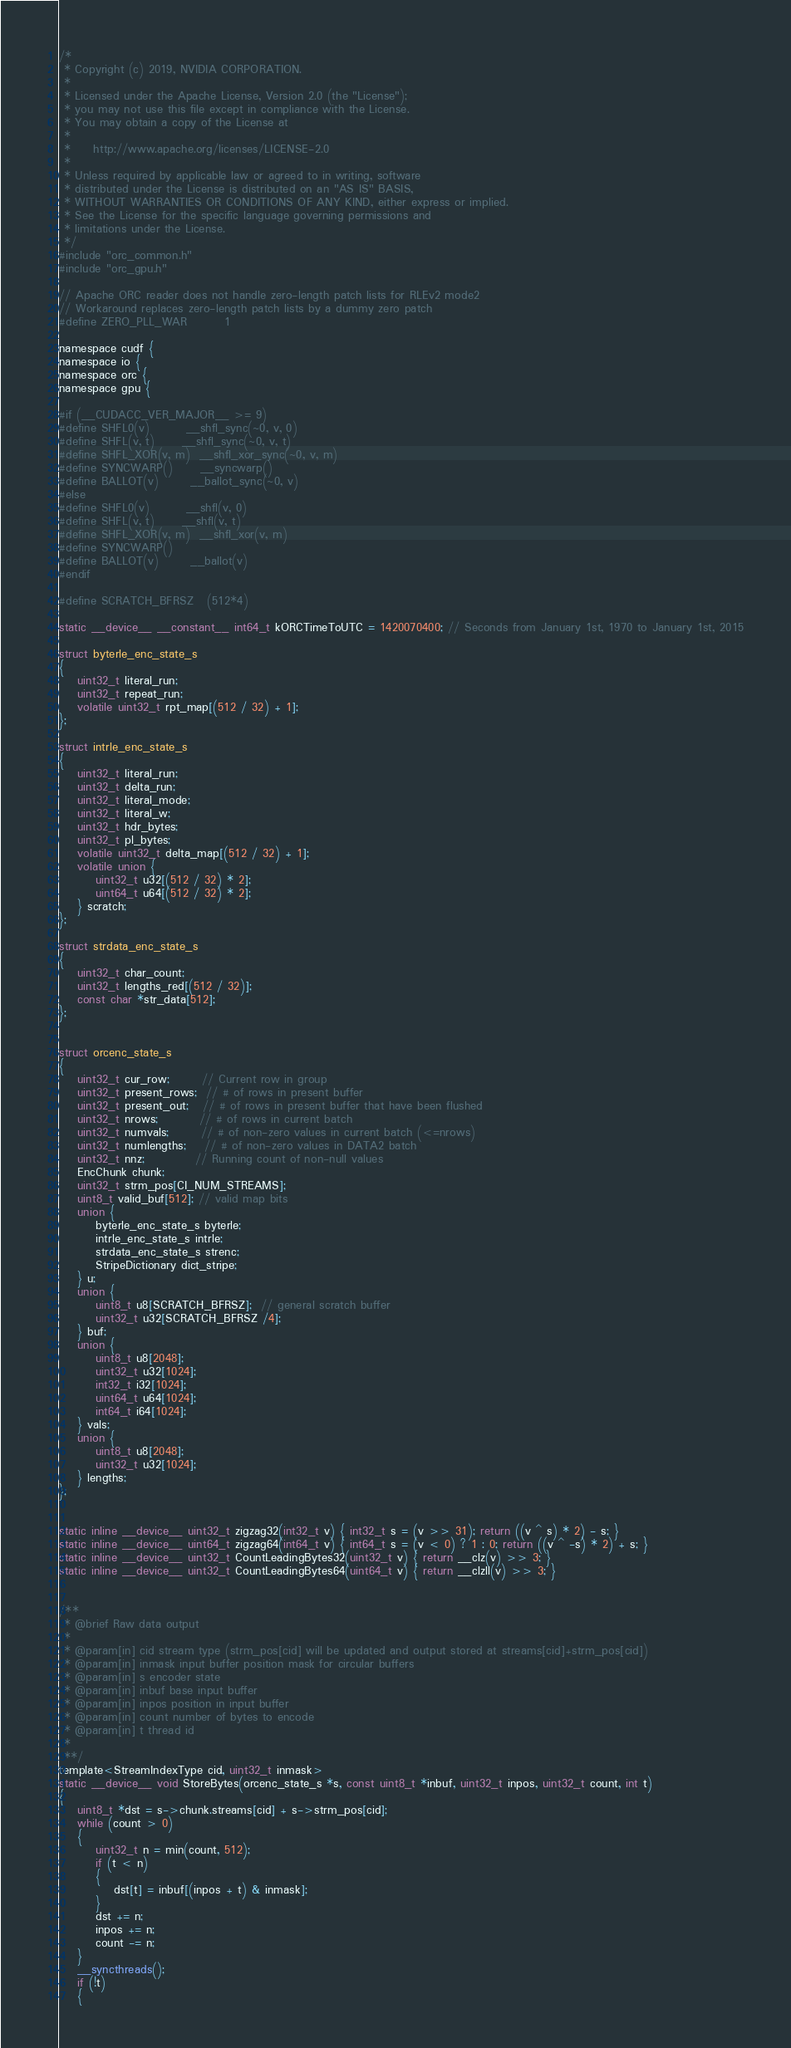<code> <loc_0><loc_0><loc_500><loc_500><_Cuda_>/*
 * Copyright (c) 2019, NVIDIA CORPORATION.
 *
 * Licensed under the Apache License, Version 2.0 (the "License");
 * you may not use this file except in compliance with the License.
 * You may obtain a copy of the License at
 *
 *     http://www.apache.org/licenses/LICENSE-2.0
 *
 * Unless required by applicable law or agreed to in writing, software
 * distributed under the License is distributed on an "AS IS" BASIS,
 * WITHOUT WARRANTIES OR CONDITIONS OF ANY KIND, either express or implied.
 * See the License for the specific language governing permissions and
 * limitations under the License.
 */
#include "orc_common.h"
#include "orc_gpu.h"

// Apache ORC reader does not handle zero-length patch lists for RLEv2 mode2
// Workaround replaces zero-length patch lists by a dummy zero patch
#define ZERO_PLL_WAR        1

namespace cudf {
namespace io {
namespace orc {
namespace gpu {

#if (__CUDACC_VER_MAJOR__ >= 9)
#define SHFL0(v)        __shfl_sync(~0, v, 0)
#define SHFL(v, t)      __shfl_sync(~0, v, t)
#define SHFL_XOR(v, m)  __shfl_xor_sync(~0, v, m)
#define SYNCWARP()      __syncwarp()
#define BALLOT(v)       __ballot_sync(~0, v)
#else
#define SHFL0(v)        __shfl(v, 0)
#define SHFL(v, t)      __shfl(v, t)
#define SHFL_XOR(v, m)  __shfl_xor(v, m)
#define SYNCWARP()
#define BALLOT(v)       __ballot(v)
#endif

#define SCRATCH_BFRSZ   (512*4)

static __device__ __constant__ int64_t kORCTimeToUTC = 1420070400; // Seconds from January 1st, 1970 to January 1st, 2015

struct byterle_enc_state_s
{
    uint32_t literal_run;
    uint32_t repeat_run;
    volatile uint32_t rpt_map[(512 / 32) + 1];
};

struct intrle_enc_state_s
{
    uint32_t literal_run;
    uint32_t delta_run;
    uint32_t literal_mode;
    uint32_t literal_w;
    uint32_t hdr_bytes;
    uint32_t pl_bytes;
    volatile uint32_t delta_map[(512 / 32) + 1];
    volatile union {
        uint32_t u32[(512 / 32) * 2];
        uint64_t u64[(512 / 32) * 2];
    } scratch;
};

struct strdata_enc_state_s
{
    uint32_t char_count;
    uint32_t lengths_red[(512 / 32)];
    const char *str_data[512];
};


struct orcenc_state_s
{
    uint32_t cur_row;       // Current row in group
    uint32_t present_rows;  // # of rows in present buffer
    uint32_t present_out;   // # of rows in present buffer that have been flushed
    uint32_t nrows;         // # of rows in current batch
    uint32_t numvals;       // # of non-zero values in current batch (<=nrows)
    uint32_t numlengths;    // # of non-zero values in DATA2 batch
    uint32_t nnz;           // Running count of non-null values
    EncChunk chunk;
    uint32_t strm_pos[CI_NUM_STREAMS];
    uint8_t valid_buf[512]; // valid map bits
    union {
        byterle_enc_state_s byterle;
        intrle_enc_state_s intrle;
        strdata_enc_state_s strenc;
        StripeDictionary dict_stripe;
    } u;
    union {
        uint8_t u8[SCRATCH_BFRSZ];  // general scratch buffer
        uint32_t u32[SCRATCH_BFRSZ /4];
    } buf;
    union {
        uint8_t u8[2048];
        uint32_t u32[1024];
        int32_t i32[1024];
        uint64_t u64[1024];
        int64_t i64[1024];
    } vals;
    union {
        uint8_t u8[2048];
        uint32_t u32[1024];
    } lengths;
};


static inline __device__ uint32_t zigzag32(int32_t v) { int32_t s = (v >> 31); return ((v ^ s) * 2) - s; }
static inline __device__ uint64_t zigzag64(int64_t v) { int64_t s = (v < 0) ? 1 : 0; return ((v ^ -s) * 2) + s; }
static inline __device__ uint32_t CountLeadingBytes32(uint32_t v) { return __clz(v) >> 3; }
static inline __device__ uint32_t CountLeadingBytes64(uint64_t v) { return __clzll(v) >> 3; }


/**
 * @brief Raw data output
 *
 * @param[in] cid stream type (strm_pos[cid] will be updated and output stored at streams[cid]+strm_pos[cid])
 * @param[in] inmask input buffer position mask for circular buffers
 * @param[in] s encoder state
 * @param[in] inbuf base input buffer
 * @param[in] inpos position in input buffer
 * @param[in] count number of bytes to encode
 * @param[in] t thread id
 *
 **/
template<StreamIndexType cid, uint32_t inmask>
static __device__ void StoreBytes(orcenc_state_s *s, const uint8_t *inbuf, uint32_t inpos, uint32_t count, int t)
{
    uint8_t *dst = s->chunk.streams[cid] + s->strm_pos[cid];
    while (count > 0)
    {
        uint32_t n = min(count, 512);
        if (t < n)
        {
            dst[t] = inbuf[(inpos + t) & inmask];
        }
        dst += n;
        inpos += n;
        count -= n;
    }
    __syncthreads();
    if (!t)
    {</code> 